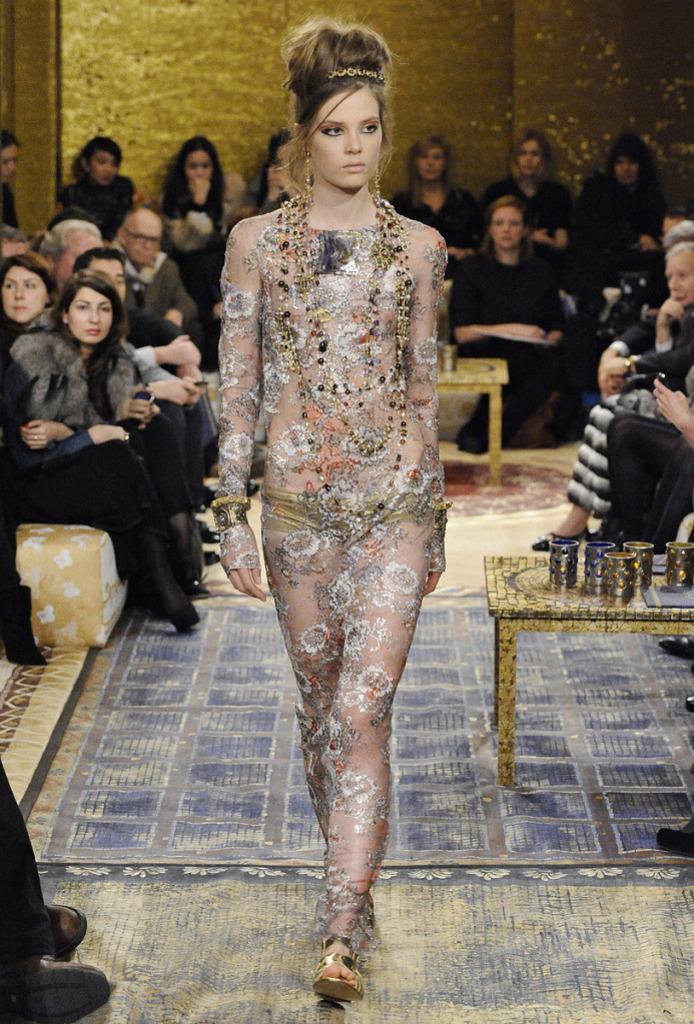What is the woman in the image doing? The woman is walking in the image. What are the people in the image doing? There is a group of people sitting in the image. What objects are on the table in the image? There are glasses on a table in the image. What is visible in the background of the image? There is a wall visible in the image. What is at the bottom of the image? There is a mat at the bottom of the image. What type of beef is being served on the desk in the image? There is no beef or desk present in the image. How does the woman plan to burn the mat at the bottom of the image? There is no indication of any burning or intention to burn in the image. 